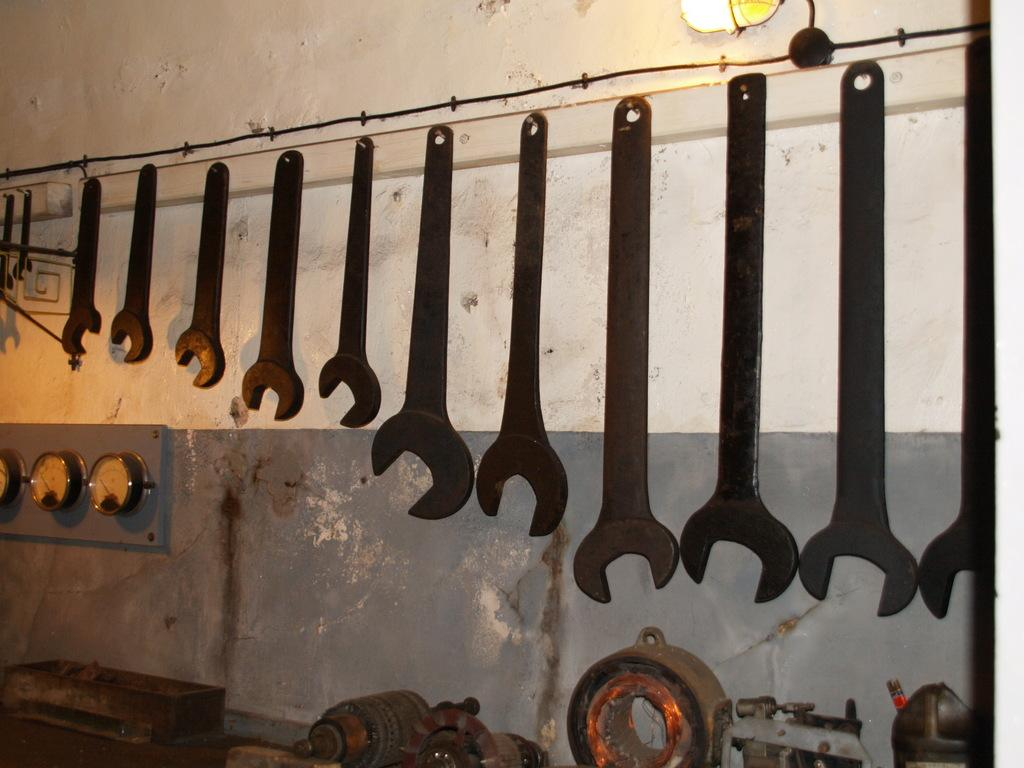What types of objects can be seen in the image? There are tools, meters, and machines in the image. What is the purpose of the meters in the image? The meters are likely used to measure or monitor something related to the tools or machines. Can you describe the background of the image? There is a wall in the background of the image. What type of illumination is present in the image? There is a light in the image. What channel is the authority using to communicate with the people in the image? There is no channel or authority present in the image; it features tools, meters, machines, a wall, and a light. 